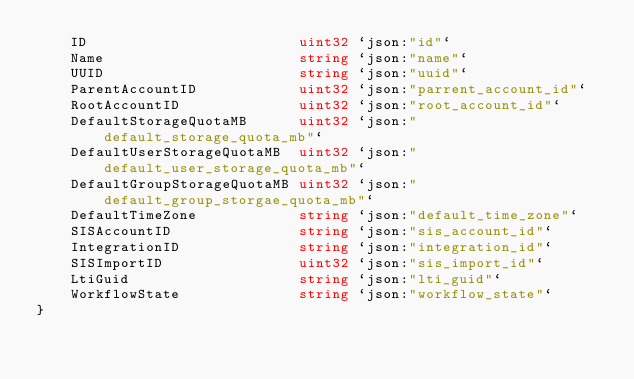<code> <loc_0><loc_0><loc_500><loc_500><_Go_>	ID                         uint32 `json:"id"`
	Name                       string `json:"name"`
	UUID                       string `json:"uuid"`
	ParentAccountID            uint32 `json:"parrent_account_id"`
	RootAccountID              uint32 `json:"root_account_id"`
	DefaultStorageQuotaMB      uint32 `json:"default_storage_quota_mb"`
	DefaultUserStorageQuotaMB  uint32 `json:"default_user_storage_quota_mb"`
	DefaultGroupStorageQuotaMB uint32 `json:"default_group_storgae_quota_mb"`
	DefaultTimeZone            string `json:"default_time_zone"`
	SISAccountID               string `json:"sis_account_id"`
	IntegrationID              string `json:"integration_id"`
	SISImportID                uint32 `json:"sis_import_id"`
	LtiGuid                    string `json:"lti_guid"`
	WorkflowState              string `json:"workflow_state"`
}
</code> 